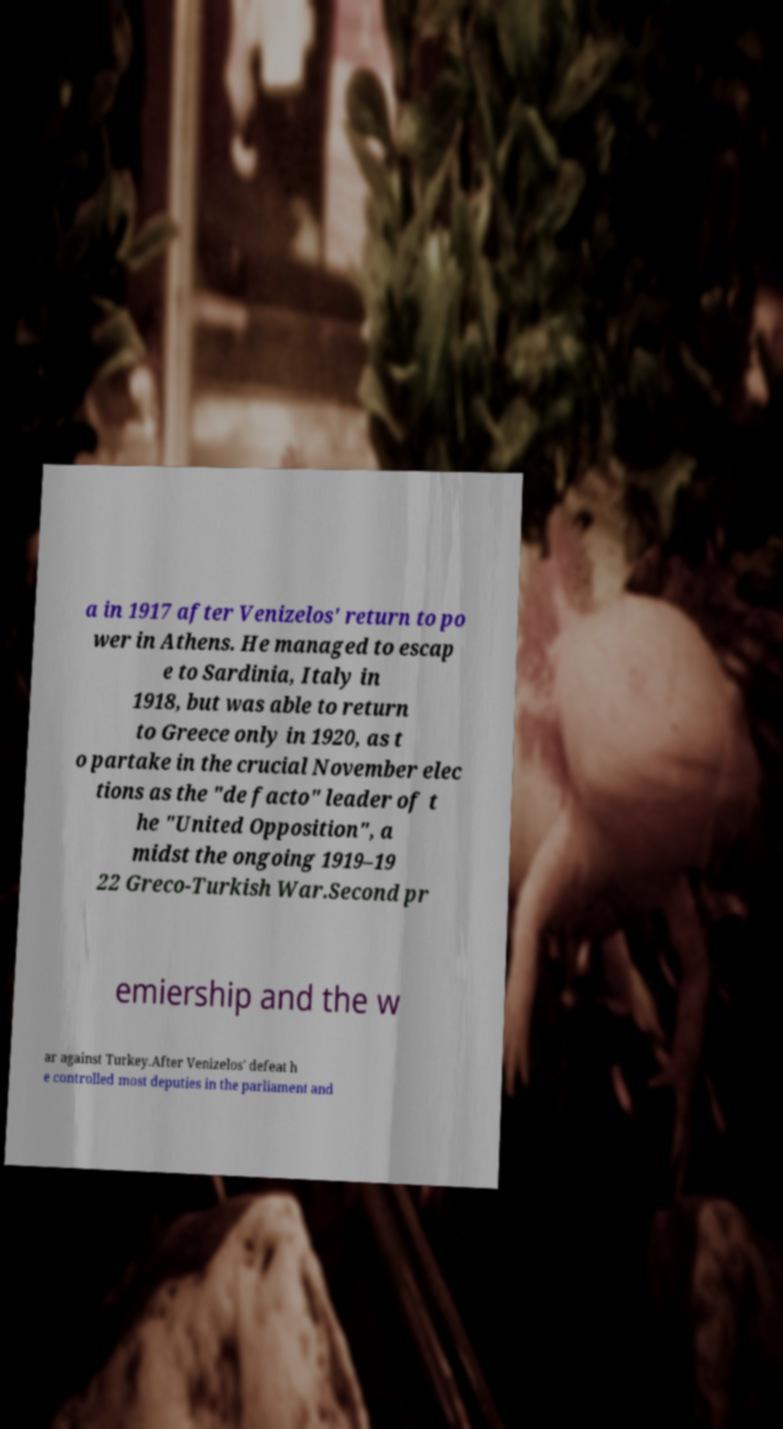Can you accurately transcribe the text from the provided image for me? a in 1917 after Venizelos' return to po wer in Athens. He managed to escap e to Sardinia, Italy in 1918, but was able to return to Greece only in 1920, as t o partake in the crucial November elec tions as the "de facto" leader of t he "United Opposition", a midst the ongoing 1919–19 22 Greco-Turkish War.Second pr emiership and the w ar against Turkey.After Venizelos' defeat h e controlled most deputies in the parliament and 